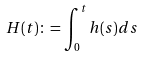Convert formula to latex. <formula><loc_0><loc_0><loc_500><loc_500>H ( t ) \colon = \int _ { 0 } ^ { t } h ( s ) d s</formula> 